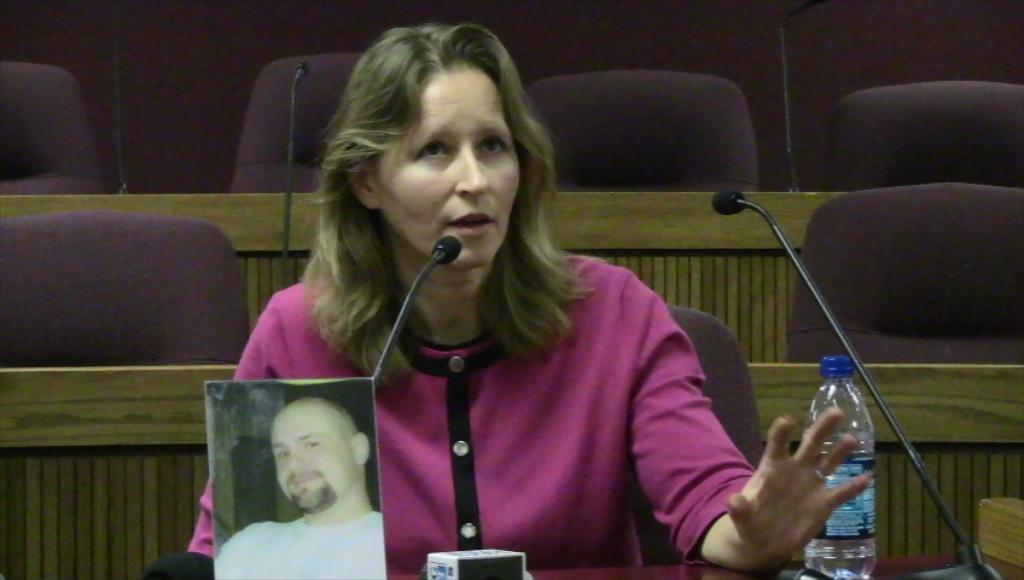Who is present in the image? There is a lady in the image. What objects are present in the image that might be used for seating? There are many chairs in the image. What objects are present in the image that might be used for amplifying sound? There are microphones in the image. What object is present in the image that might be used for holding items? There is a table in the image. What objects are present on the table in the image? There is a photo and a bottle on the table, along with other items. What type of wool can be seen in the image? There is no wool present in the image. What guide is the lady using in the image? There is no guide present in the image. 